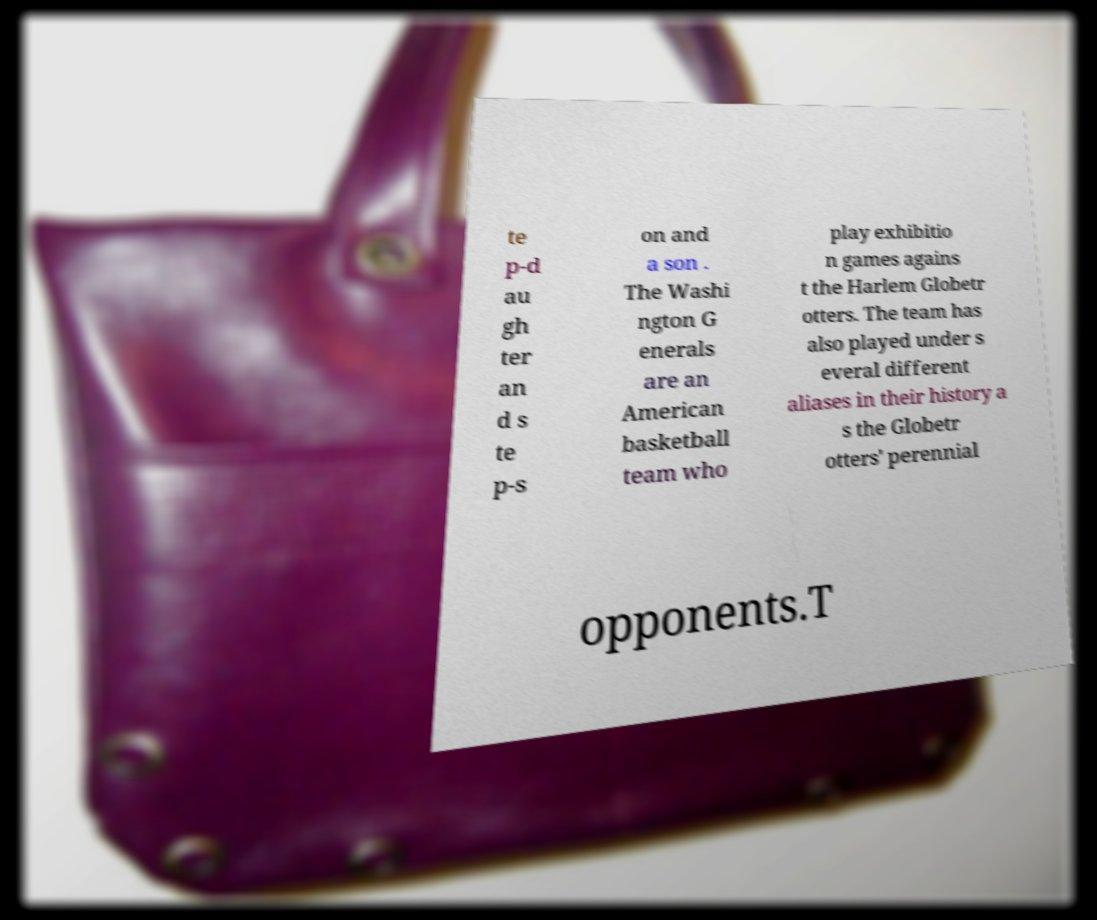Can you accurately transcribe the text from the provided image for me? te p-d au gh ter an d s te p-s on and a son . The Washi ngton G enerals are an American basketball team who play exhibitio n games agains t the Harlem Globetr otters. The team has also played under s everal different aliases in their history a s the Globetr otters' perennial opponents.T 